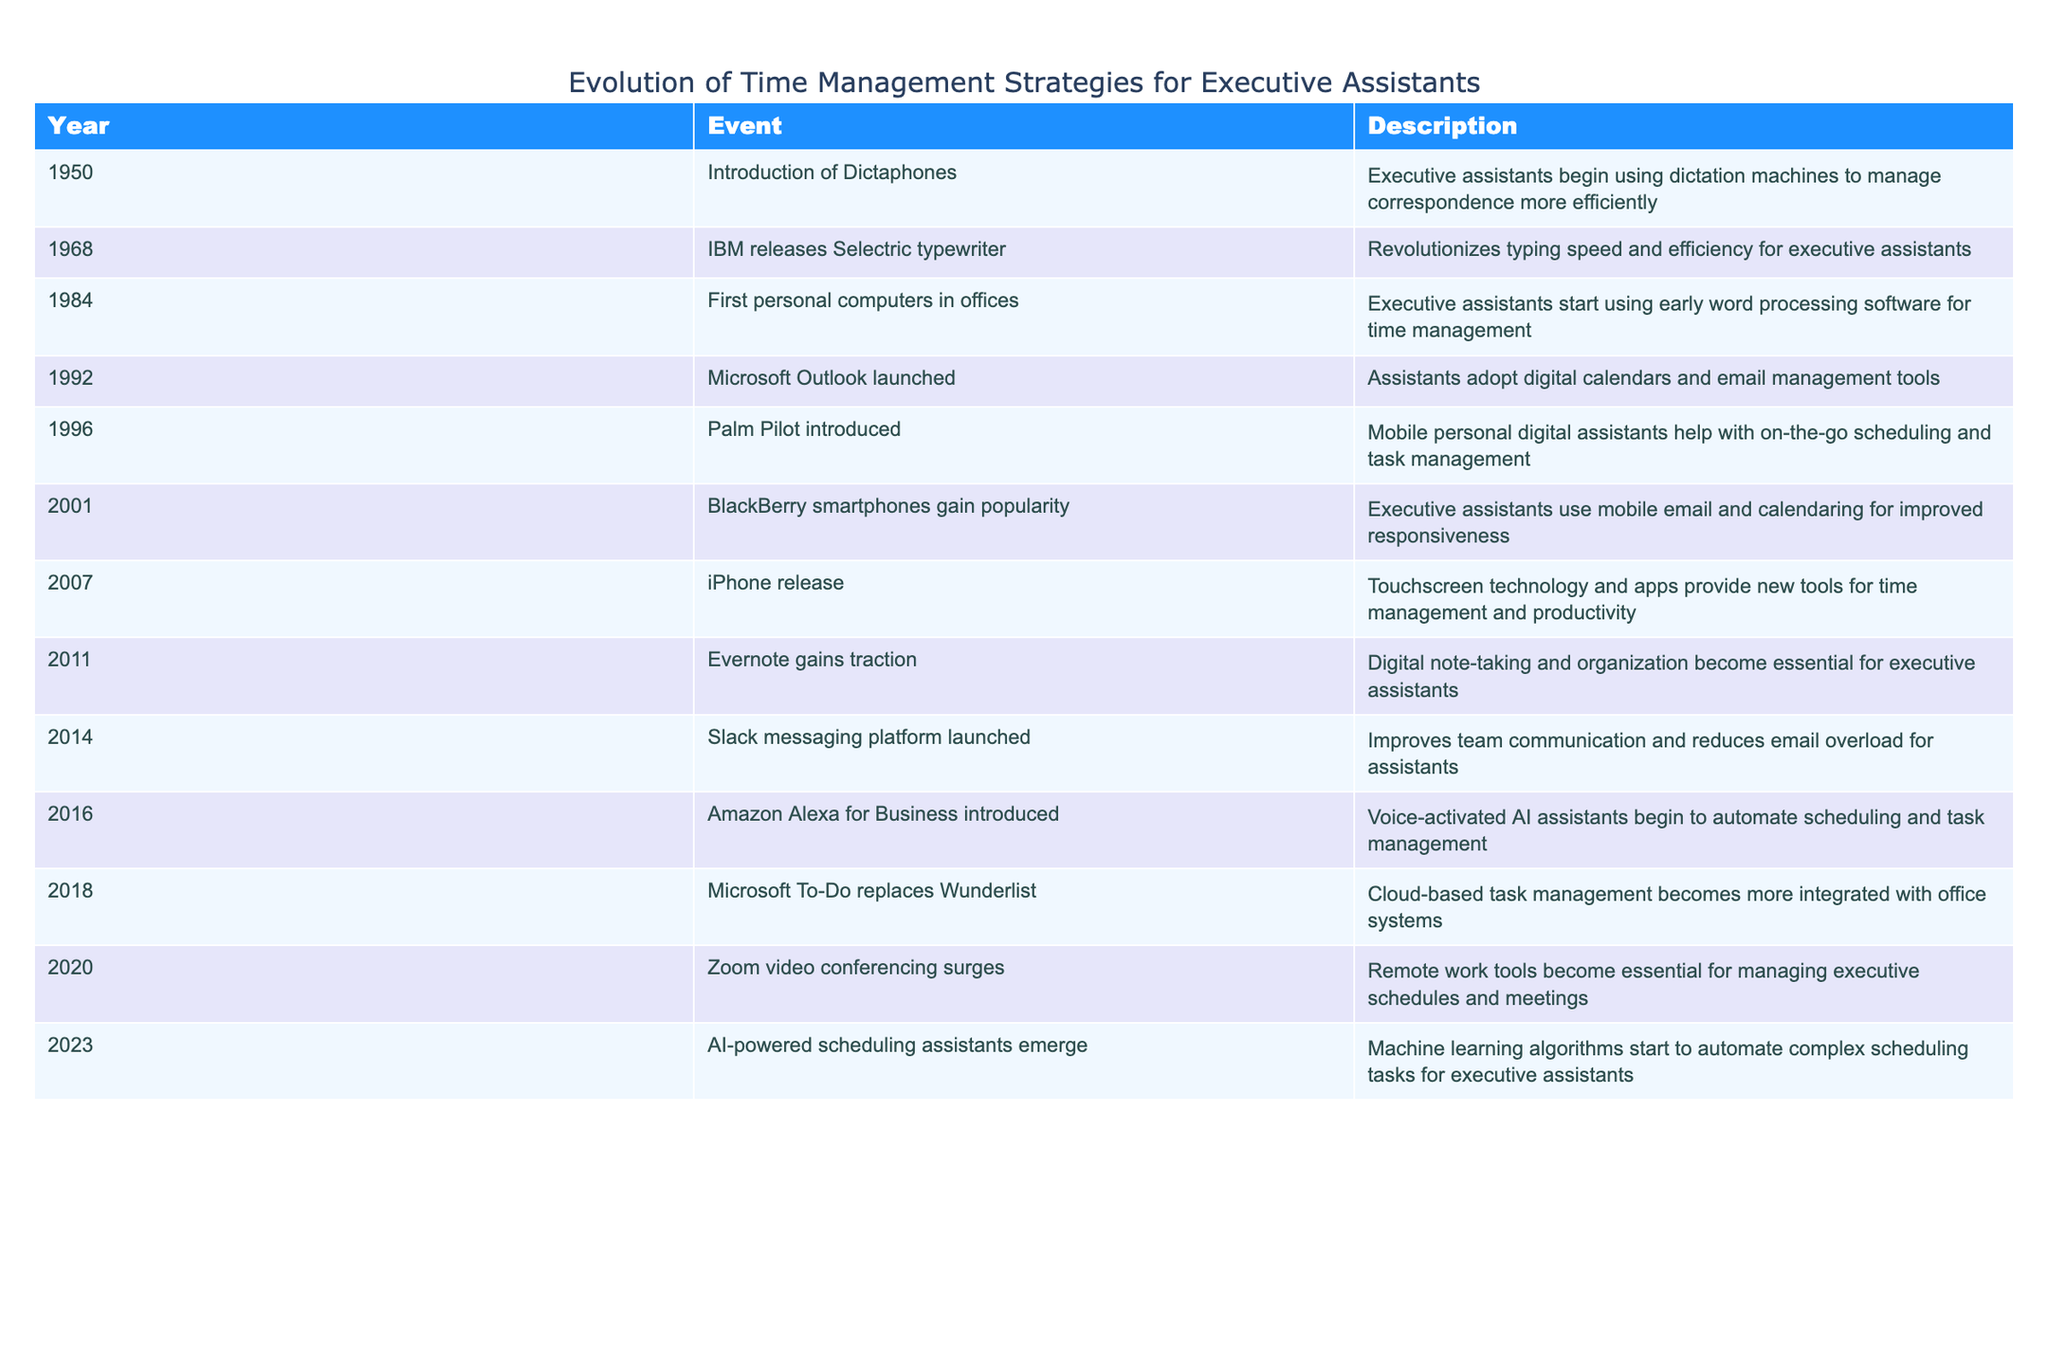What was the first major technological advancement for executive assistants? The table indicates that the first major advancement was the introduction of Dictaphones in 1950, which helped executive assistants manage correspondence more efficiently.
Answer: Dictaphones Which year did Microsoft Outlook launch? According to the table, Microsoft Outlook was launched in 1992, which marked a significant development in digital calendars and email management tools for executive assistants.
Answer: 1992 How many years elapsed between the introduction of the Palm Pilot and the release of the iPhone? The Palm Pilot was introduced in 1996 and the iPhone was released in 2007. The difference in years is 2007 - 1996 = 11 years.
Answer: 11 years True or False: The introduction of Amazon Alexa for Business happened before Slack was launched. The table shows that Slack was introduced in 2014 and Amazon Alexa for Business in 2016, confirming that Slack was indeed launched first.
Answer: True What type of technology emerged in 2023 and how does it differ from previous tools? The table states that AI-powered scheduling assistants emerged in 2023, which utilize machine learning algorithms to automate complex scheduling tasks, differing from earlier tools that required more manual input.
Answer: AI-powered scheduling assistants How many significant advancements occurred between 2000 and 2020? Referring to the table, the advancements during this period are: BlackBerry (2001), iPhone (2007), Evernote (2011), Slack (2014), and Zoom (2020). Counting these gives a total of 5 significant advancements.
Answer: 5 Which event marked the beginning of mobile time management tools for executive assistants? The introduction of the Palm Pilot in 1996 is identified as the starting point for mobile personal digital assistants that aided in scheduling and task management for executive assistants.
Answer: Palm Pilot What percentage of the years listed involved an advancement in communication tools? The table shows advancements in 1968 (typewriter), 1992 (Outlook), 1996 (Palm Pilot), 2001 (BlackBerry), 2014 (Slack), and 2020 (Zoom). There are a total of 6 advancements out of 11 years, resulting in 6/11 ≈ 54.55%.
Answer: Approximately 54.55% What were the two key time management technologies introduced in the late 1990s? The table details that the Palm Pilot was introduced in 1996 and Microsoft Outlook was launched in 1992, both of which were crucial for time management for executive assistants.
Answer: Palm Pilot and Microsoft Outlook 